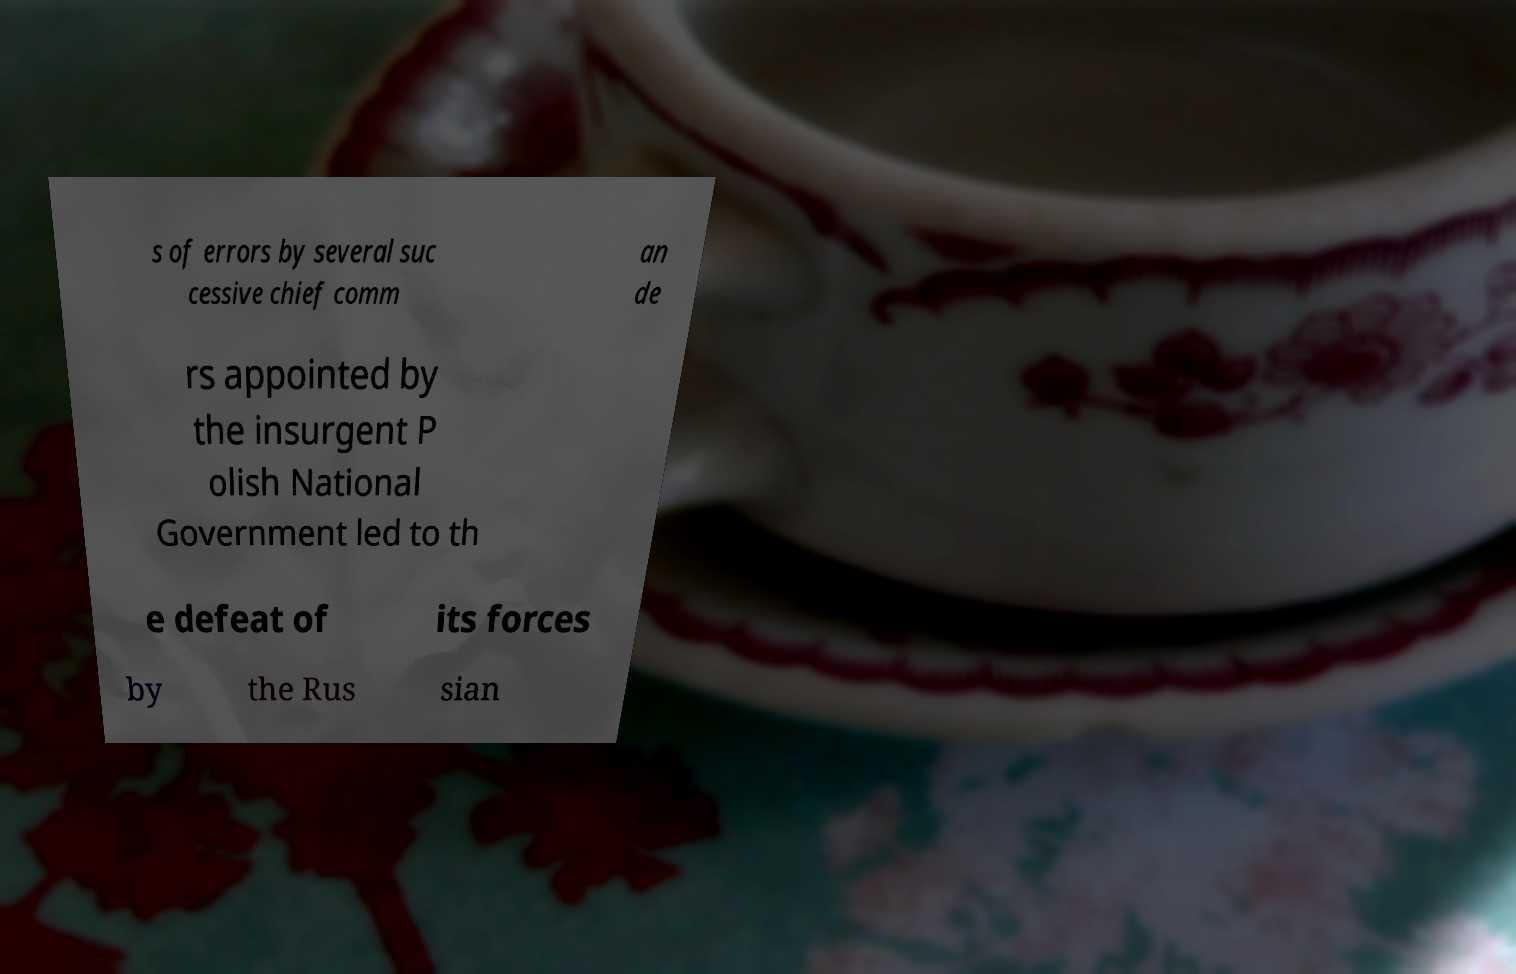For documentation purposes, I need the text within this image transcribed. Could you provide that? s of errors by several suc cessive chief comm an de rs appointed by the insurgent P olish National Government led to th e defeat of its forces by the Rus sian 